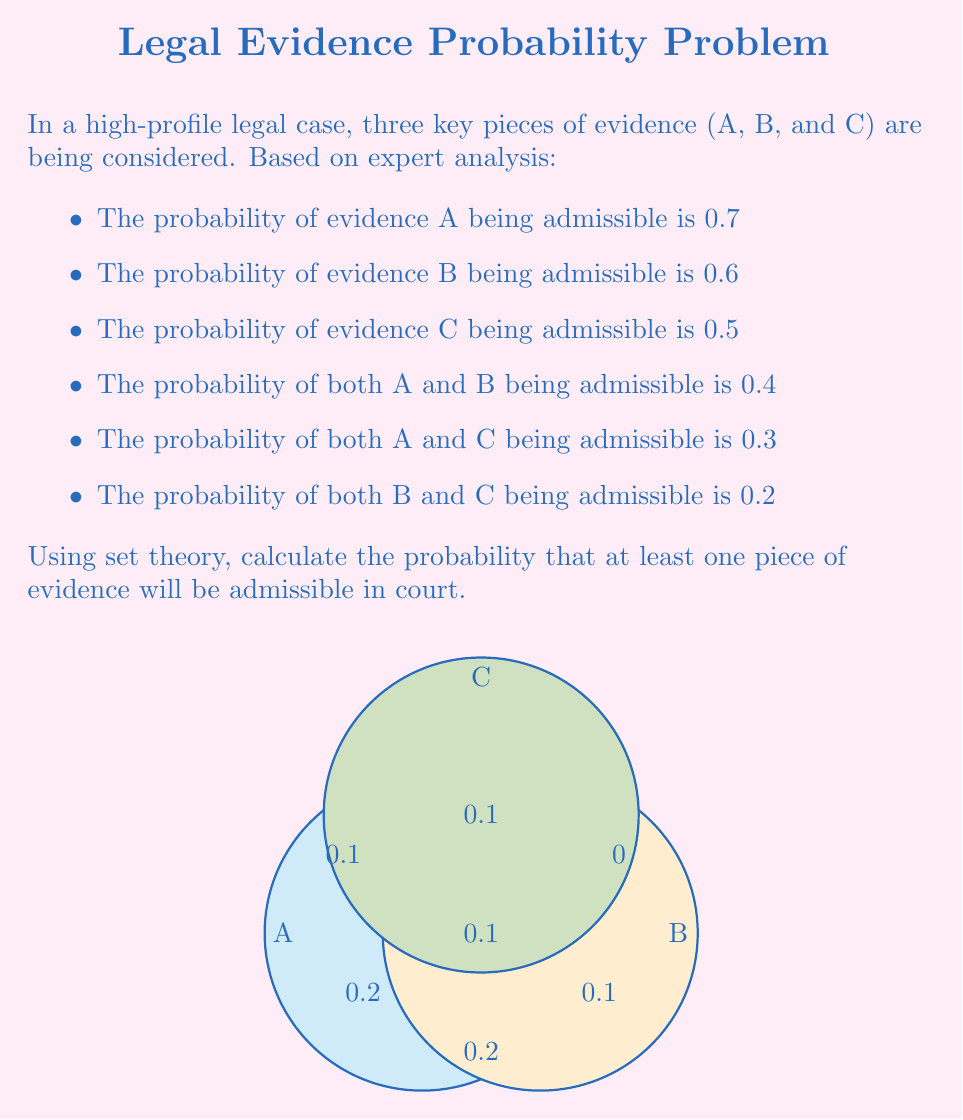Help me with this question. Let's approach this step-by-step using set theory and the principle of inclusion-exclusion:

1) Let's define our sets:
   $A$: Evidence A is admissible
   $B$: Evidence B is admissible
   $C$: Evidence C is admissible

2) We're given:
   $P(A) = 0.7$
   $P(B) = 0.6$
   $P(C) = 0.5$
   $P(A \cap B) = 0.4$
   $P(A \cap C) = 0.3$
   $P(B \cap C) = 0.2$

3) We need to find $P(A \cup B \cup C)$, which is the probability that at least one piece of evidence is admissible.

4) Using the principle of inclusion-exclusion:

   $P(A \cup B \cup C) = P(A) + P(B) + P(C) - P(A \cap B) - P(A \cap C) - P(B \cap C) + P(A \cap B \cap C)$

5) We know all terms except $P(A \cap B \cap C)$. We can find this using the given information:

   $P(A) + P(B) - P(A \cup B) = P(A \cap B)$
   $0.7 + 0.6 - P(A \cup B) = 0.4$
   $P(A \cup B) = 0.9$

   Similarly:
   $P(A \cup C) = 0.9$
   $P(B \cup C) = 0.9$

6) Now we can use these to find $P(A \cap B \cap C)$:

   $P(A \cup B \cup C) = P(A) + P(B) + P(C) - P(A \cap B) - P(A \cap C) - P(B \cap C) + P(A \cap B \cap C)$
   $0.9 = 0.7 + 0.6 + 0.5 - 0.4 - 0.3 - 0.2 + P(A \cap B \cap C)$
   $P(A \cap B \cap C) = 0.9 - 1.8 + 0.9 = 0$

7) Now we can calculate $P(A \cup B \cup C)$:

   $P(A \cup B \cup C) = 0.7 + 0.6 + 0.5 - 0.4 - 0.3 - 0.2 + 0 = 0.9$

Therefore, the probability that at least one piece of evidence will be admissible is 0.9 or 90%.
Answer: 0.9 